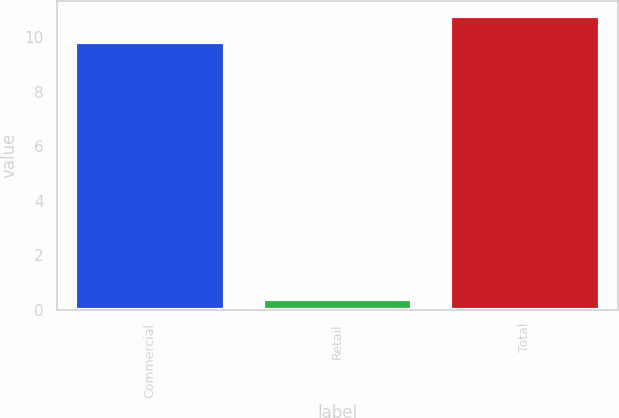Convert chart. <chart><loc_0><loc_0><loc_500><loc_500><bar_chart><fcel>Commercial<fcel>Retail<fcel>Total<nl><fcel>9.8<fcel>0.4<fcel>10.78<nl></chart> 